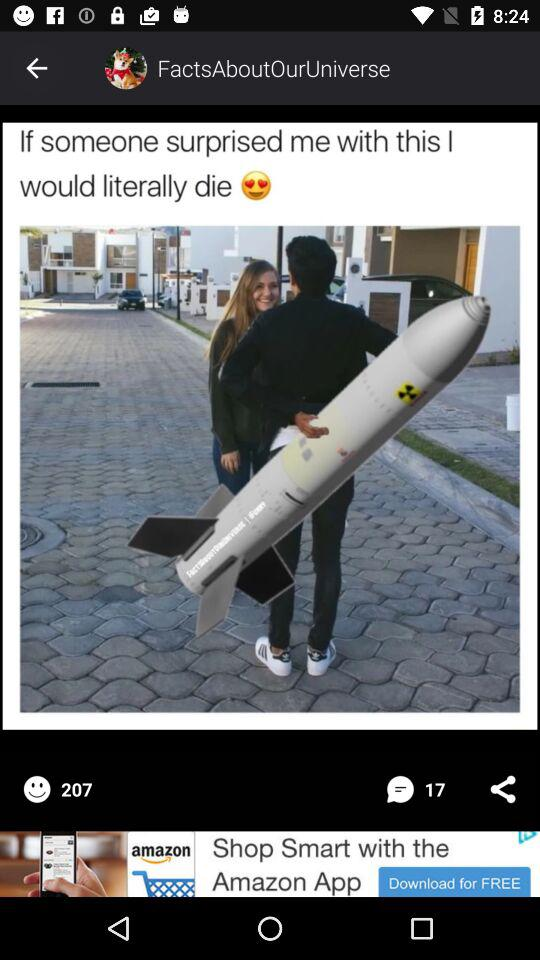How many smileys are there? There are 207 smileys. 